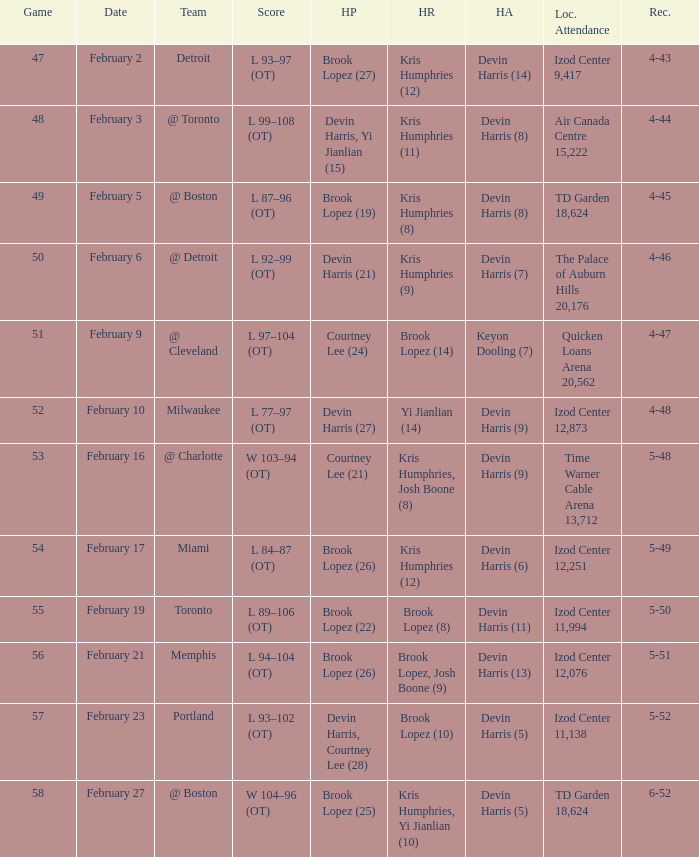What team was the game on February 27 played against? @ Boston. 